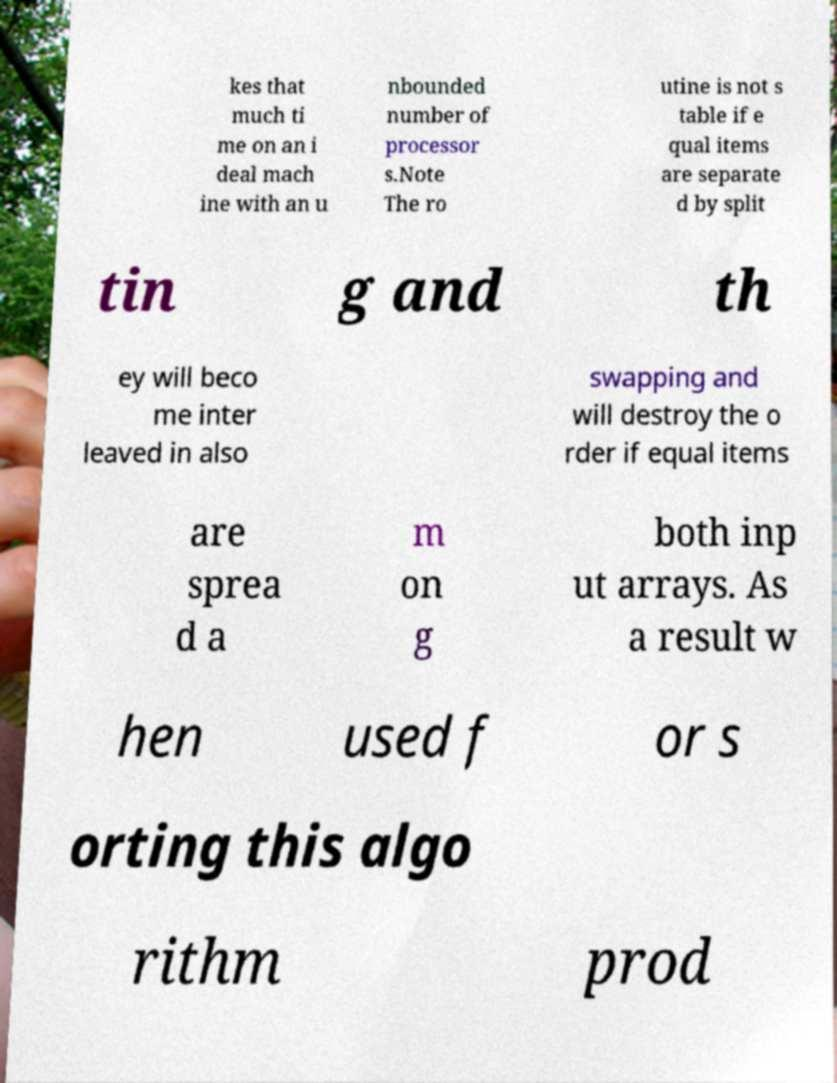Could you extract and type out the text from this image? kes that much ti me on an i deal mach ine with an u nbounded number of processor s.Note The ro utine is not s table if e qual items are separate d by split tin g and th ey will beco me inter leaved in also swapping and will destroy the o rder if equal items are sprea d a m on g both inp ut arrays. As a result w hen used f or s orting this algo rithm prod 